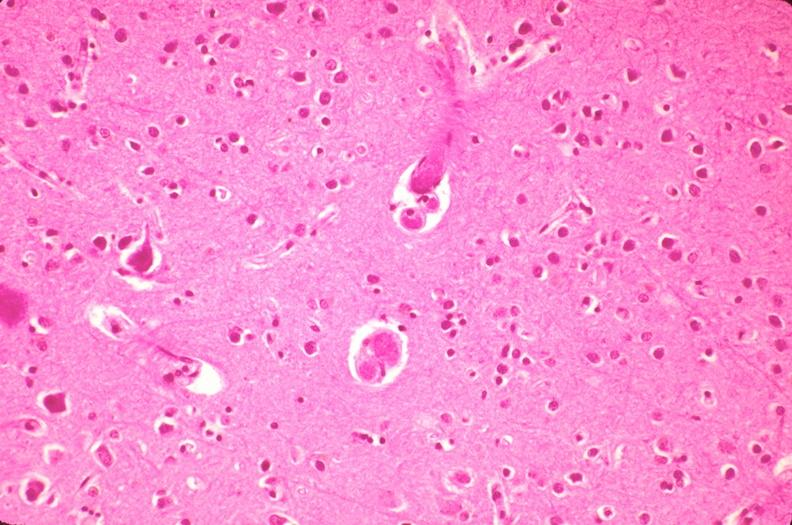what does this image show?
Answer the question using a single word or phrase. Brain 